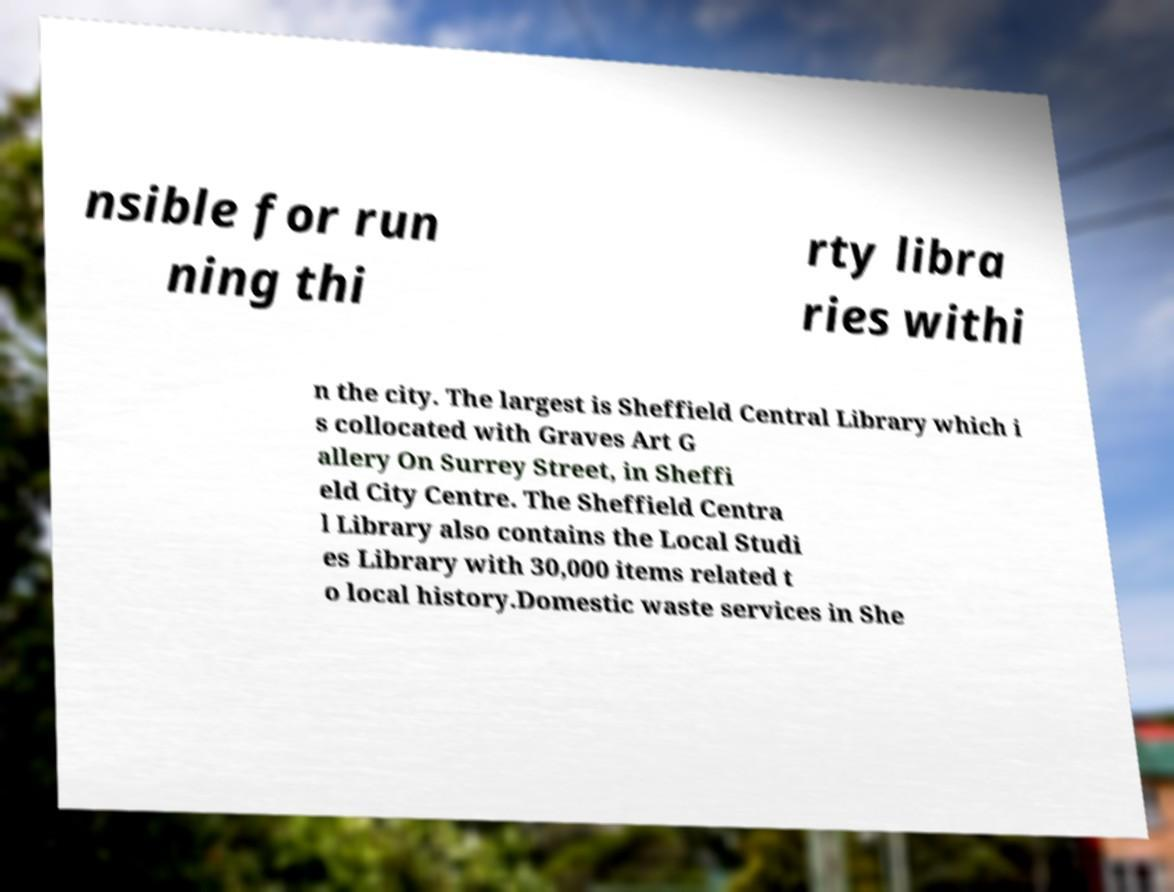What messages or text are displayed in this image? I need them in a readable, typed format. nsible for run ning thi rty libra ries withi n the city. The largest is Sheffield Central Library which i s collocated with Graves Art G allery On Surrey Street, in Sheffi eld City Centre. The Sheffield Centra l Library also contains the Local Studi es Library with 30,000 items related t o local history.Domestic waste services in She 